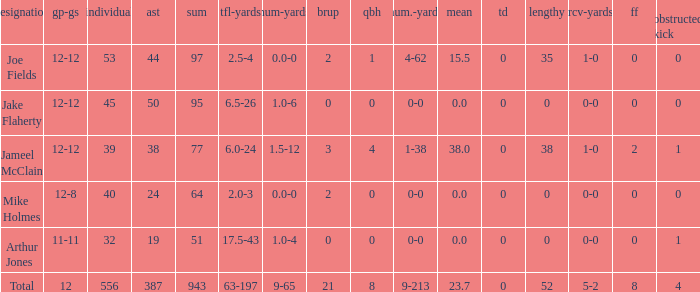What is the largest number of tds scored for a player? 0.0. 